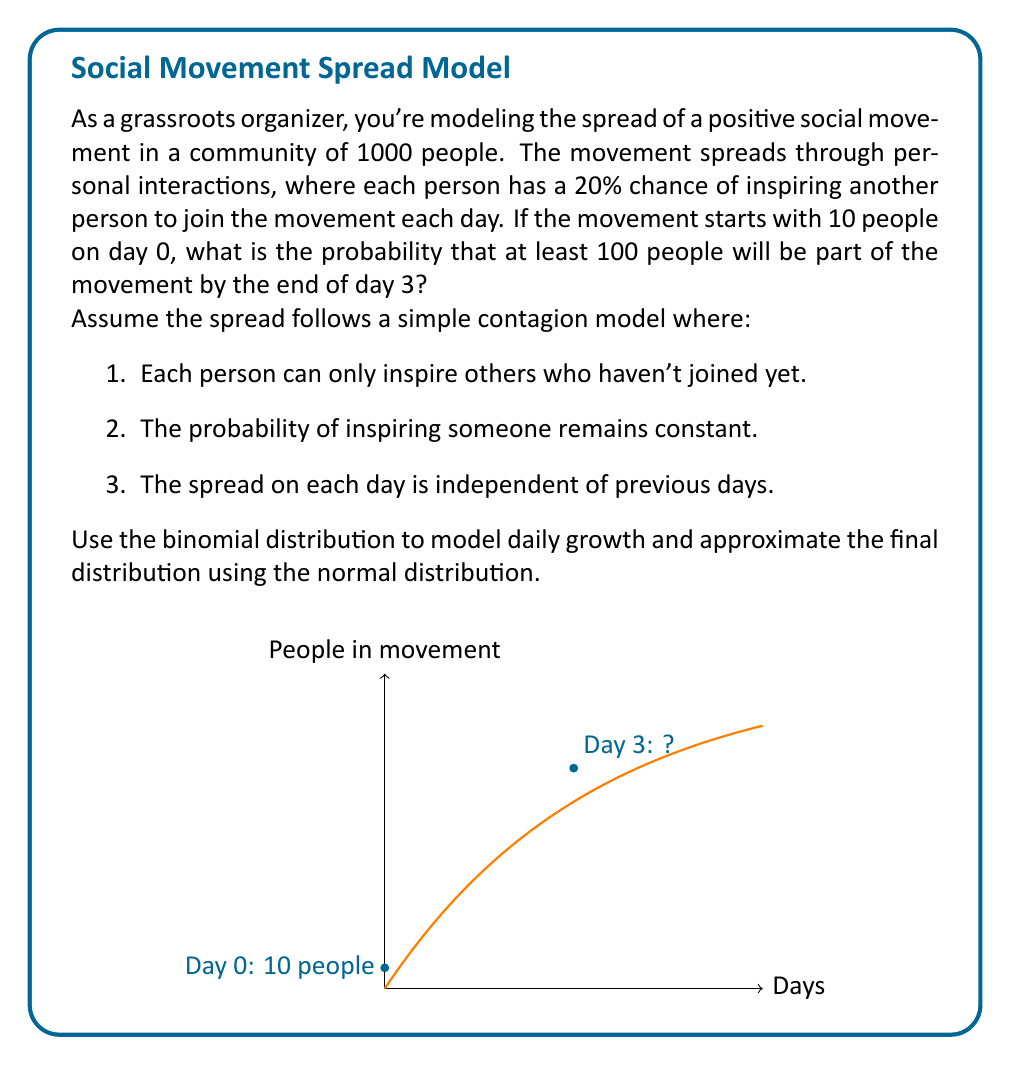Teach me how to tackle this problem. Let's approach this step-by-step:

1) First, we need to model the growth for each day using the binomial distribution.

2) On day 1:
   - We start with 10 people
   - Each can inspire up to 990 people (1000 - 10)
   - The probability of success for each attempt is 0.2
   
   This follows a Binomial(990, 0.2) distribution

3) The expected number of new people joining on day 1 is:
   $E_1 = 990 * 0.2 = 198$

4) So, the expected total after day 1 is:
   $T_1 = 10 + 198 = 208$

5) We can repeat this process for days 2 and 3, but the calculations become complex.

6) To simplify, we can approximate the final distribution using the Central Limit Theorem.

7) The variance of a binomial distribution Bin(n,p) is $np(1-p)$
   For day 1: $V_1 = 990 * 0.2 * 0.8 = 158.4$

8) Assuming similar variances for days 2 and 3, we can estimate the total variance:
   $V_{total} \approx 3 * 158.4 = 475.2$

9) The final distribution can be approximated by a normal distribution with:
   $\mu \approx 10 + 3 * 198 = 604$
   $\sigma \approx \sqrt{475.2} = 21.8$

10) We want the probability of at least 100 people, which is equivalent to the probability of not having less than 100 people.

11) Using the z-score formula:
    $z = \frac{100 - 604}{21.8} = -23.12$

12) The probability of being below this z-score is essentially 0.

Therefore, the probability of having at least 100 people by day 3 is approximately 1.
Answer: $\approx 1$ (or 99.99%) 